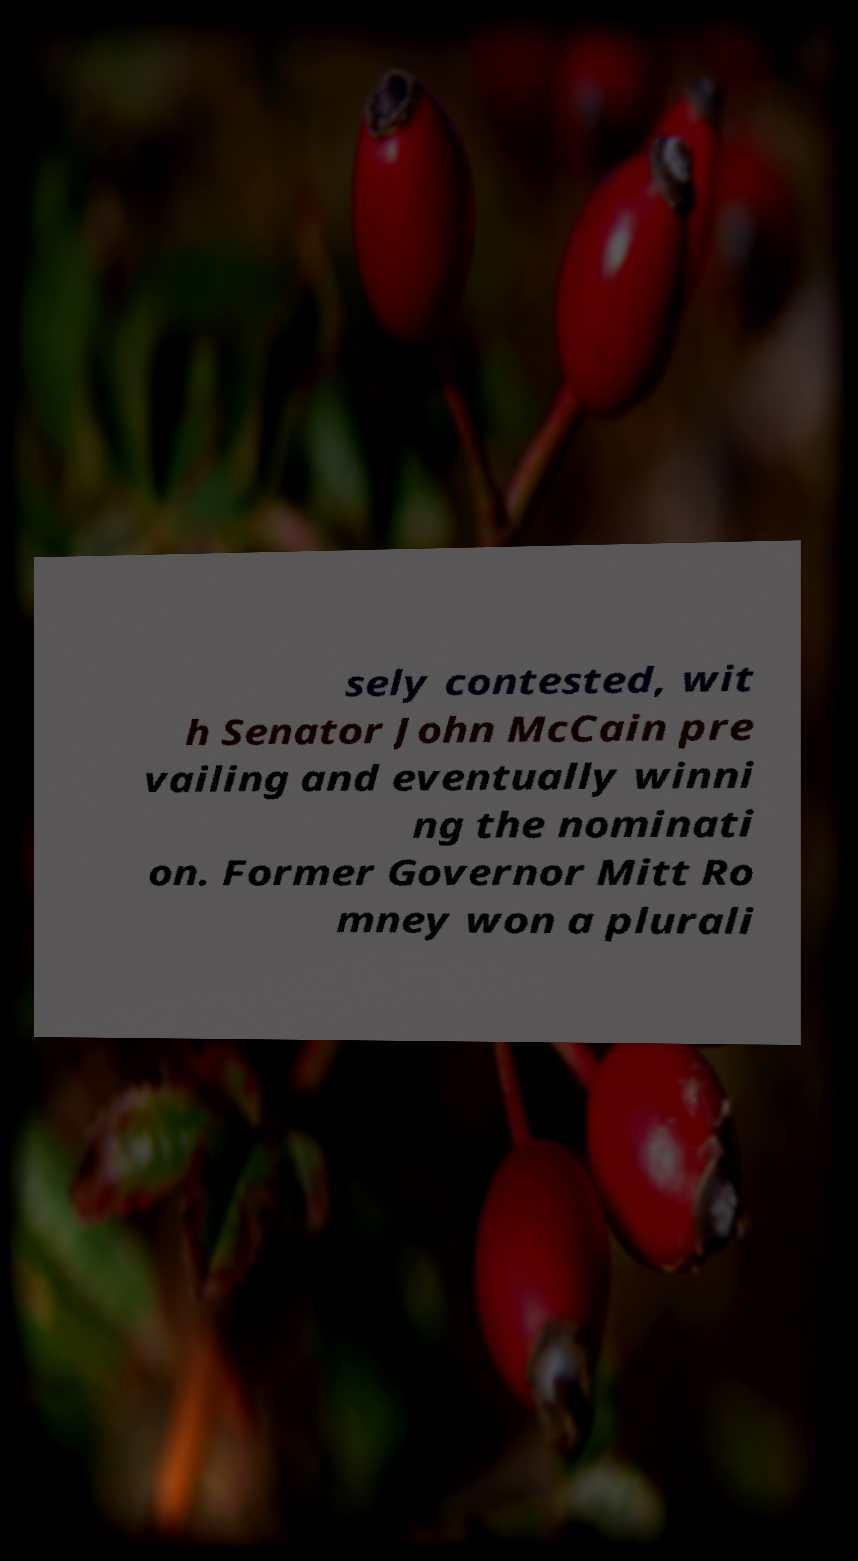What messages or text are displayed in this image? I need them in a readable, typed format. sely contested, wit h Senator John McCain pre vailing and eventually winni ng the nominati on. Former Governor Mitt Ro mney won a plurali 